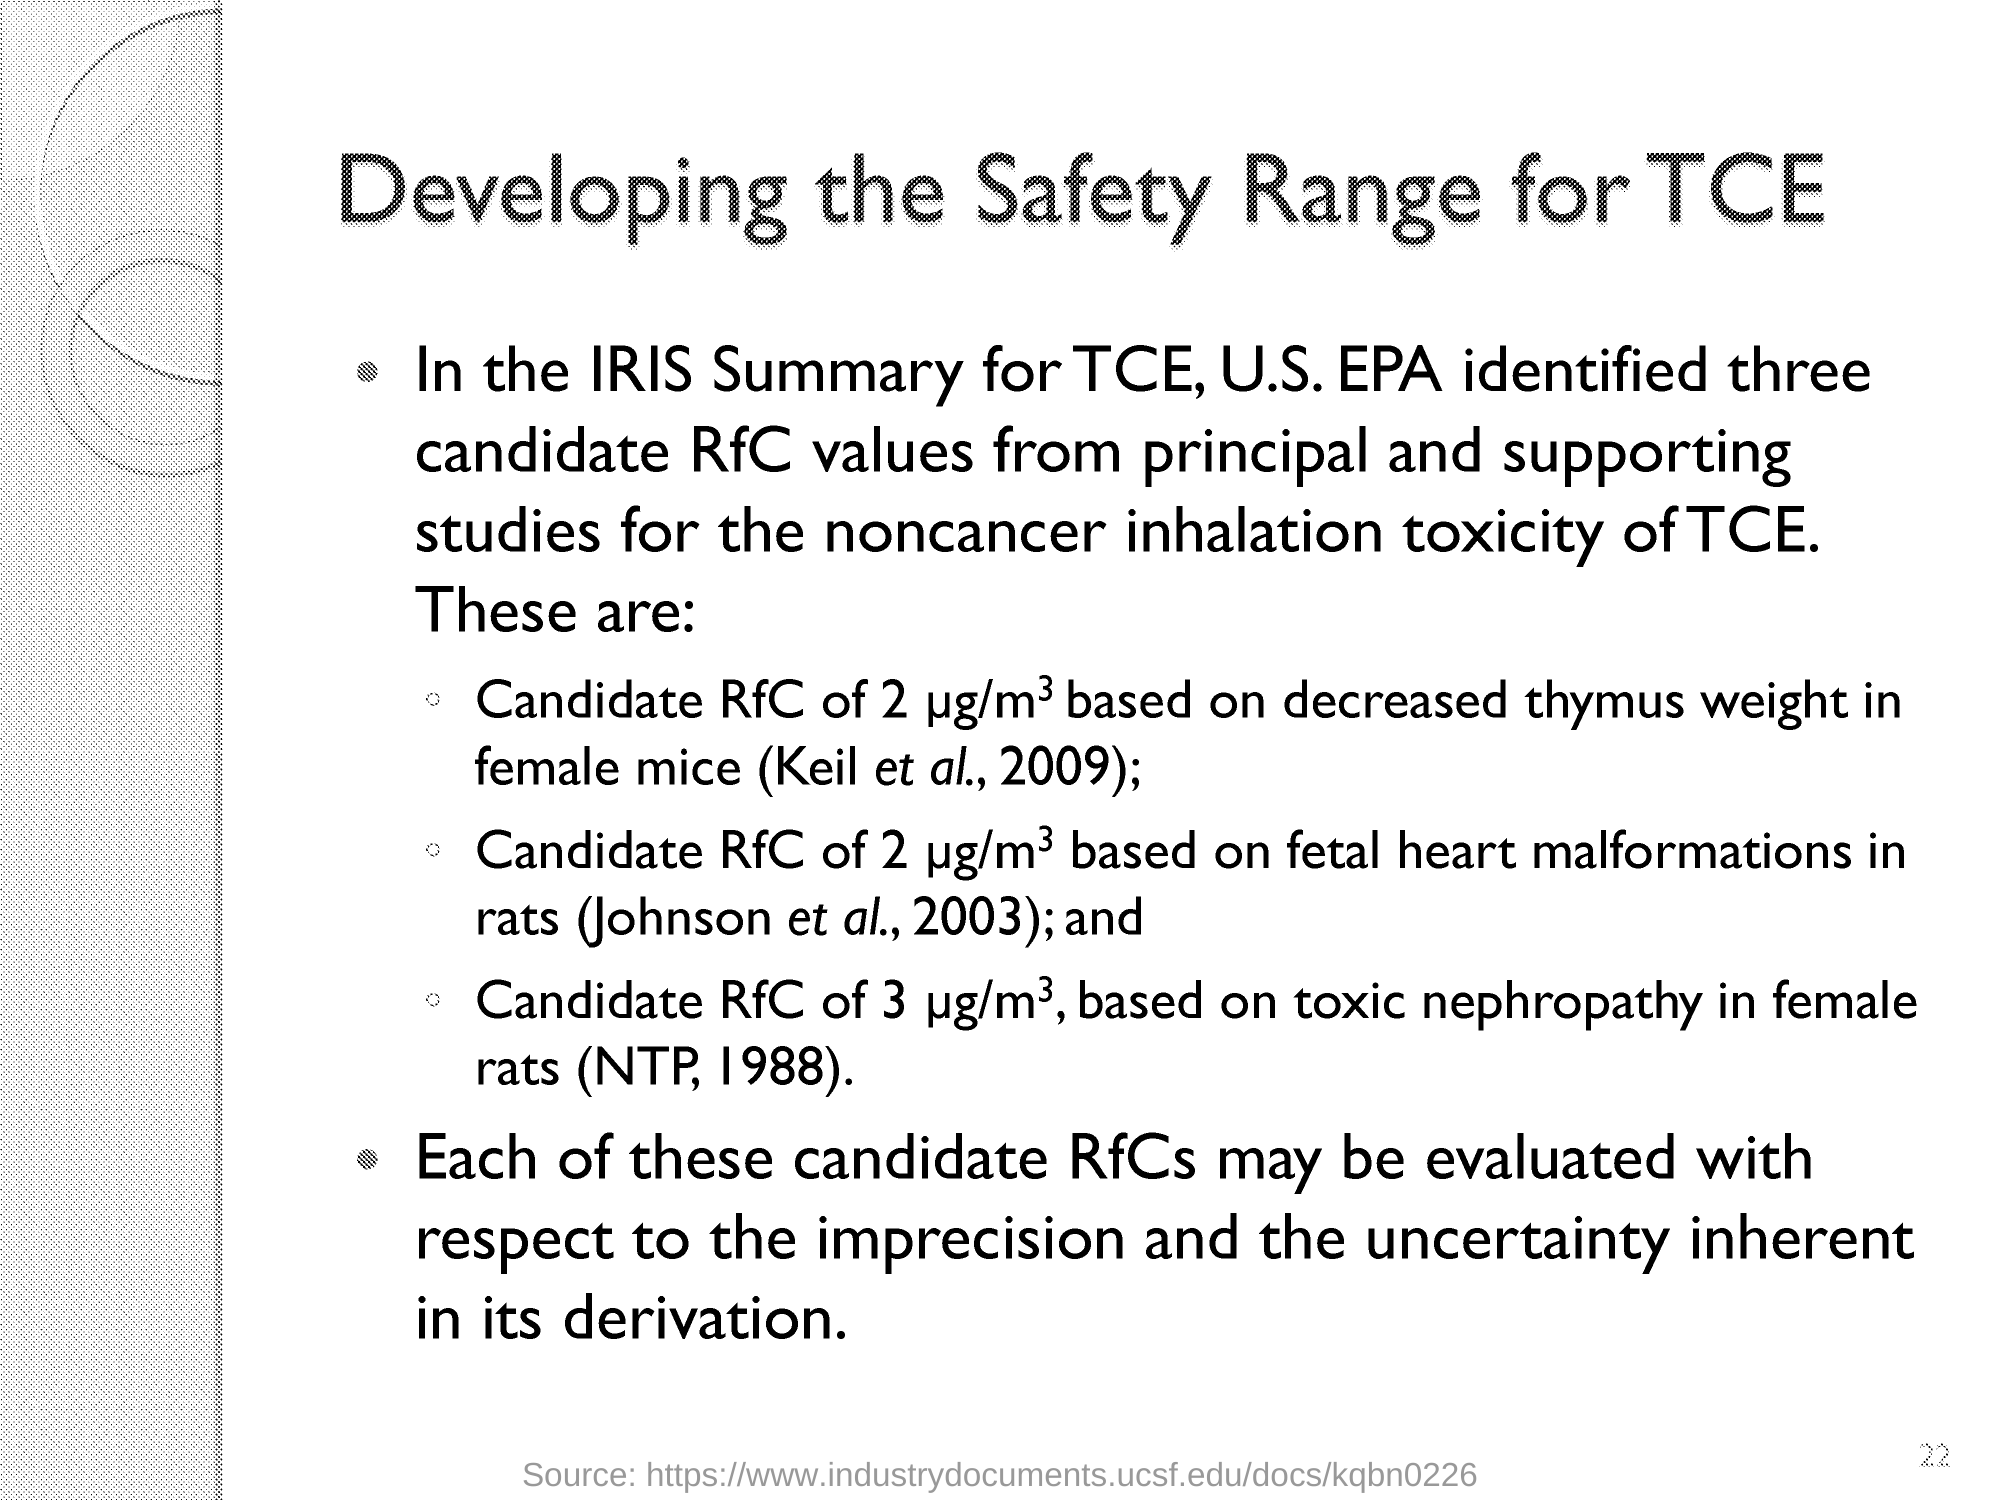Which number is lightly printed lower-right side of the document?
Keep it short and to the point. 22. 